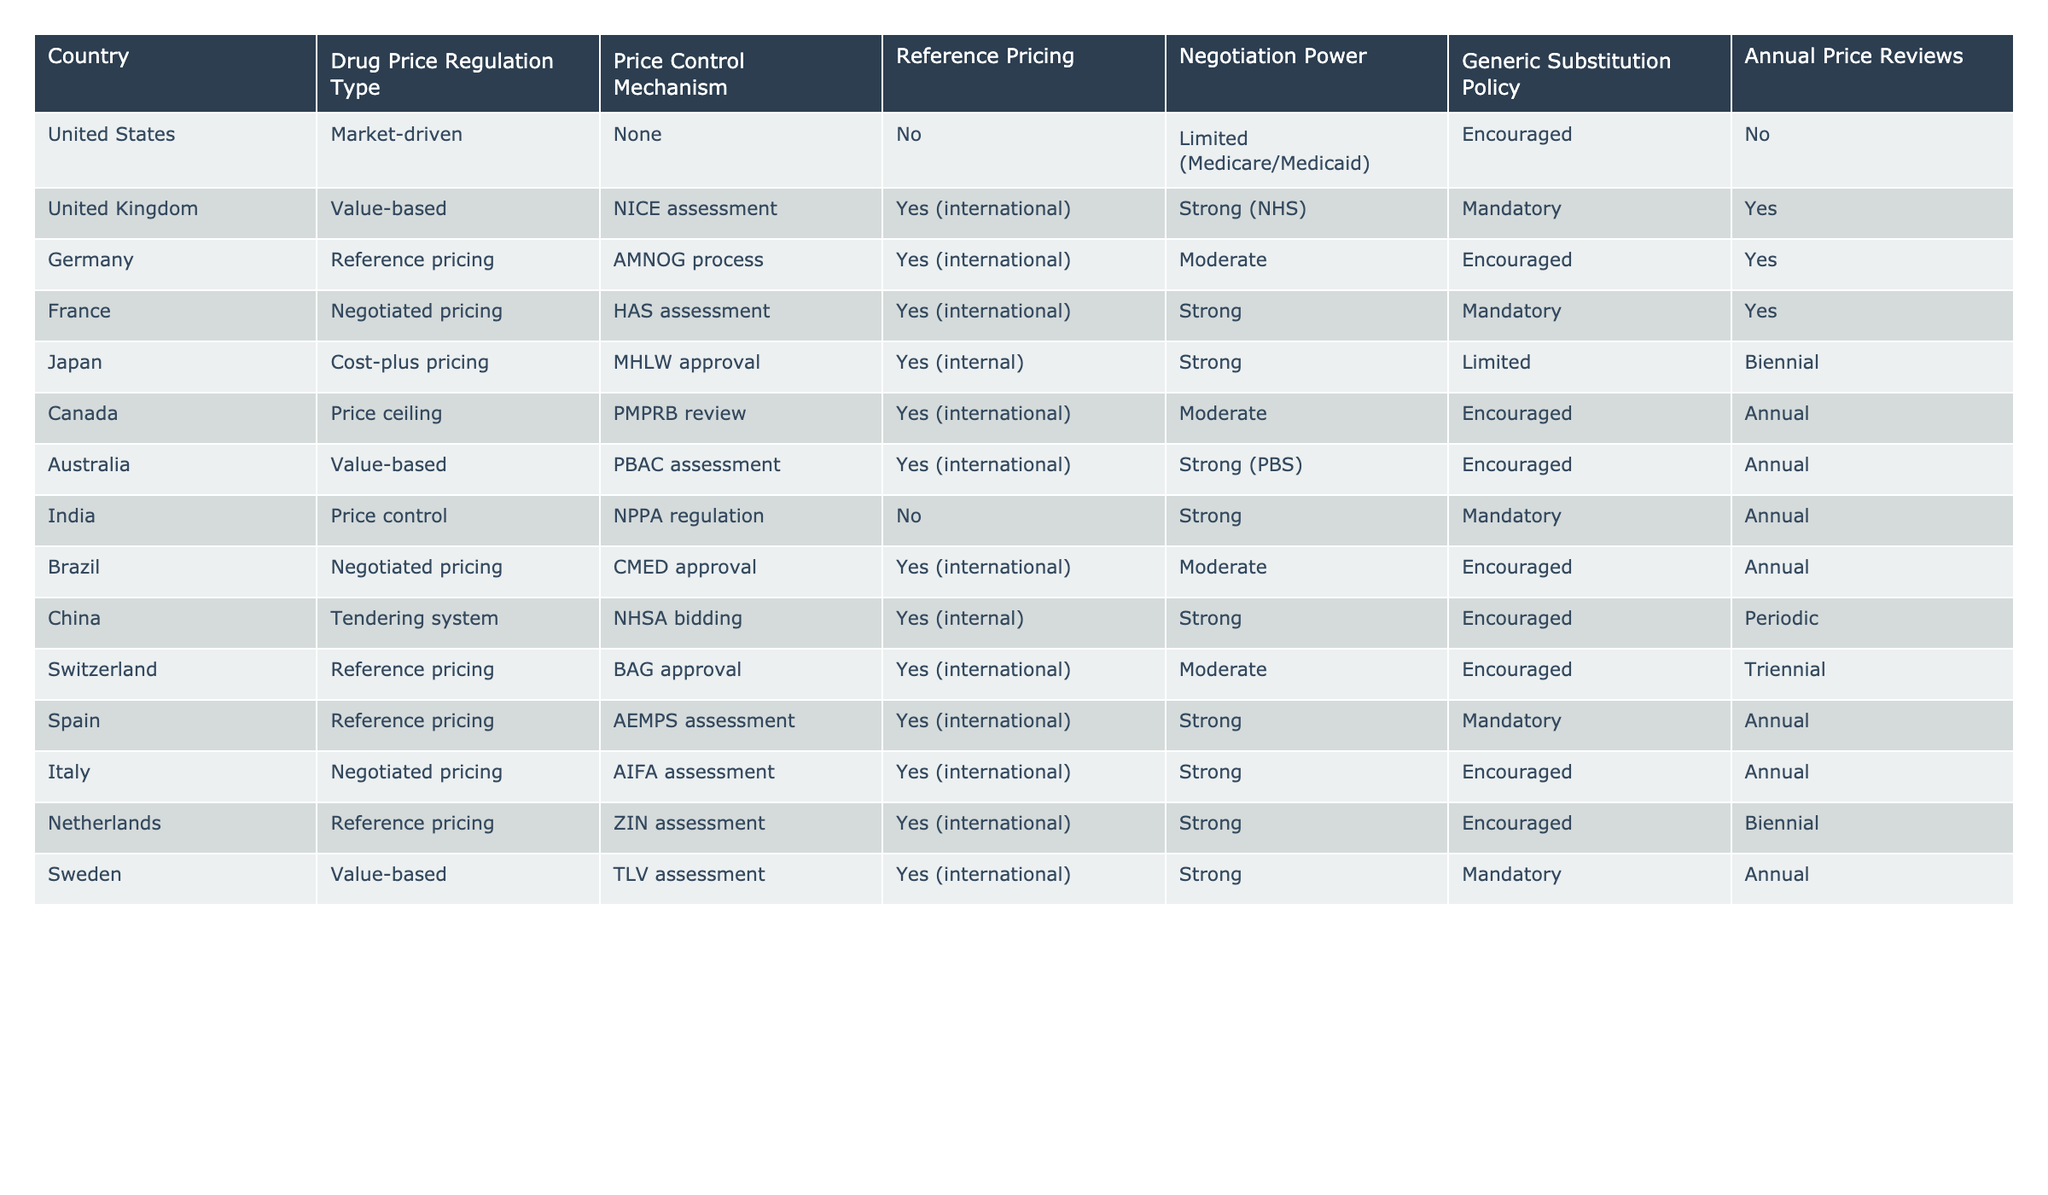What type of drug price regulation is used in Canada? According to the table, Canada uses a price ceiling as its drug price regulation type.
Answer: Price ceiling Which country has a tendering system for drug pricing? The table indicates that China has a tendering system as its drug price regulation type.
Answer: China Is Australia’s negotiation power strong or limited? The table shows that Australia has strong negotiation power in drug pricing.
Answer: Strong How often does Japan conduct annual price reviews? The table specifies that Japan conducts biennial price reviews, not annual.
Answer: Biennial Which countries implement mandatory generic substitution policies? By examining the table, the countries with mandatory generic substitution policies are the United Kingdom, France, India, Spain, and Sweden.
Answer: UK, France, India, Spain, Sweden What is the price control mechanism used in Germany? The table lists the AMNOG process as the price control mechanism for Germany.
Answer: AMNOG process Which country has moderate negotiation power and conducts annual price reviews? Canada and Brazil both have moderate negotiation power and conduct annual price reviews according to the table.
Answer: Canada, Brazil What is the average frequency of price reviews among countries with negotiated pricing? The countries with negotiated pricing are France, Italy, and Brazil. Their review frequencies are annual (2 countries) and periodic (1 country), giving an average frequency of annual.
Answer: Annual Does the United States engage in reference pricing? The table indicates that the United States does not engage in reference pricing.
Answer: No Which country has the strongest negotiation power and conducts annual price reviews? According to the table, France, Australia, and Spain all have strong negotiation power and conduct annual price reviews.
Answer: France, Australia, Spain If a country uses a cost-plus pricing mechanism, which country could it be? The table identifies Japan as the only country that uses a cost-plus pricing mechanism for drug pricing.
Answer: Japan 